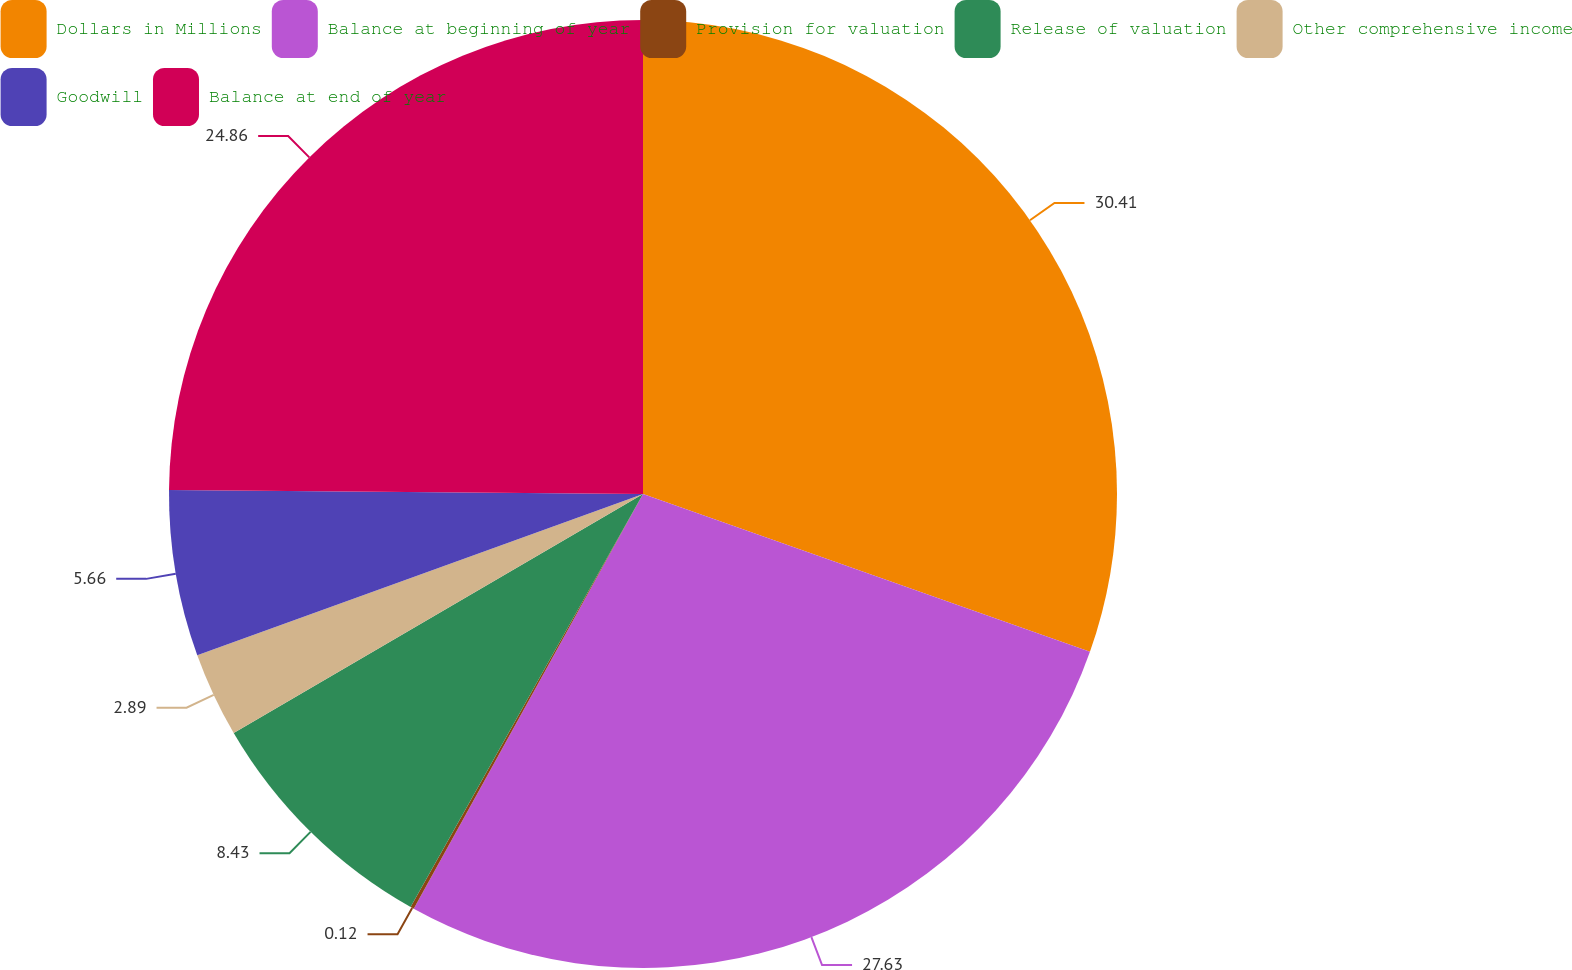Convert chart. <chart><loc_0><loc_0><loc_500><loc_500><pie_chart><fcel>Dollars in Millions<fcel>Balance at beginning of year<fcel>Provision for valuation<fcel>Release of valuation<fcel>Other comprehensive income<fcel>Goodwill<fcel>Balance at end of year<nl><fcel>30.4%<fcel>27.63%<fcel>0.12%<fcel>8.43%<fcel>2.89%<fcel>5.66%<fcel>24.86%<nl></chart> 